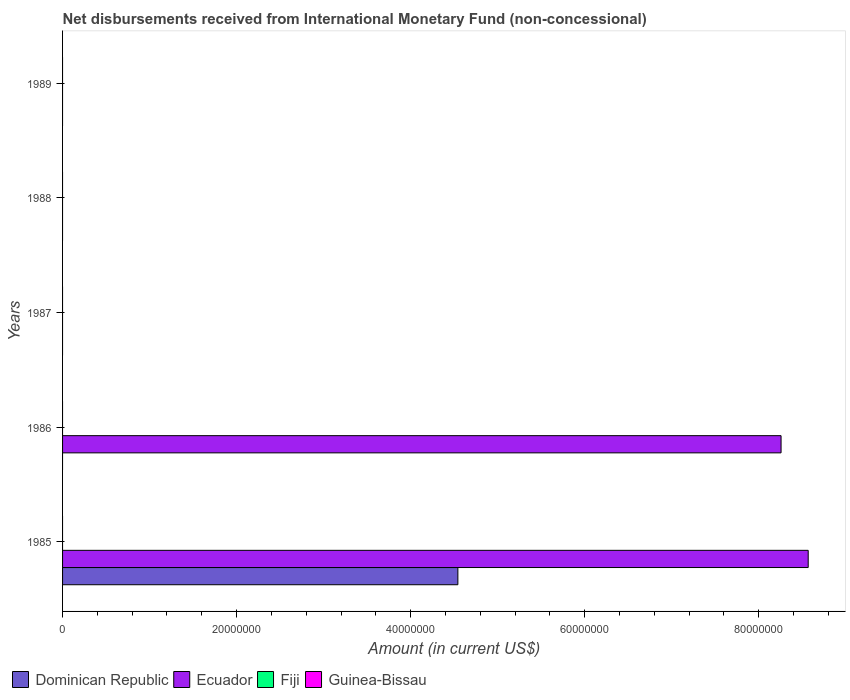How many bars are there on the 4th tick from the top?
Provide a succinct answer. 1. What is the label of the 3rd group of bars from the top?
Ensure brevity in your answer.  1987. In how many cases, is the number of bars for a given year not equal to the number of legend labels?
Your response must be concise. 5. What is the amount of disbursements received from International Monetary Fund in Ecuador in 1986?
Your response must be concise. 8.26e+07. Across all years, what is the maximum amount of disbursements received from International Monetary Fund in Ecuador?
Make the answer very short. 8.57e+07. What is the total amount of disbursements received from International Monetary Fund in Dominican Republic in the graph?
Provide a short and direct response. 4.54e+07. What is the difference between the amount of disbursements received from International Monetary Fund in Guinea-Bissau in 1987 and the amount of disbursements received from International Monetary Fund in Dominican Republic in 1985?
Keep it short and to the point. -4.54e+07. What is the average amount of disbursements received from International Monetary Fund in Dominican Republic per year?
Your response must be concise. 9.09e+06. What is the difference between the highest and the lowest amount of disbursements received from International Monetary Fund in Dominican Republic?
Your answer should be very brief. 4.54e+07. In how many years, is the amount of disbursements received from International Monetary Fund in Fiji greater than the average amount of disbursements received from International Monetary Fund in Fiji taken over all years?
Ensure brevity in your answer.  0. Is it the case that in every year, the sum of the amount of disbursements received from International Monetary Fund in Fiji and amount of disbursements received from International Monetary Fund in Dominican Republic is greater than the sum of amount of disbursements received from International Monetary Fund in Ecuador and amount of disbursements received from International Monetary Fund in Guinea-Bissau?
Provide a short and direct response. No. Is it the case that in every year, the sum of the amount of disbursements received from International Monetary Fund in Fiji and amount of disbursements received from International Monetary Fund in Guinea-Bissau is greater than the amount of disbursements received from International Monetary Fund in Ecuador?
Keep it short and to the point. No. How many years are there in the graph?
Keep it short and to the point. 5. Are the values on the major ticks of X-axis written in scientific E-notation?
Keep it short and to the point. No. Does the graph contain grids?
Give a very brief answer. No. Where does the legend appear in the graph?
Ensure brevity in your answer.  Bottom left. How many legend labels are there?
Ensure brevity in your answer.  4. What is the title of the graph?
Offer a terse response. Net disbursements received from International Monetary Fund (non-concessional). What is the label or title of the Y-axis?
Provide a succinct answer. Years. What is the Amount (in current US$) of Dominican Republic in 1985?
Provide a succinct answer. 4.54e+07. What is the Amount (in current US$) of Ecuador in 1985?
Keep it short and to the point. 8.57e+07. What is the Amount (in current US$) of Fiji in 1985?
Keep it short and to the point. 0. What is the Amount (in current US$) in Ecuador in 1986?
Make the answer very short. 8.26e+07. What is the Amount (in current US$) in Fiji in 1986?
Your response must be concise. 0. What is the Amount (in current US$) in Ecuador in 1987?
Give a very brief answer. 0. What is the Amount (in current US$) of Guinea-Bissau in 1987?
Offer a terse response. 0. What is the Amount (in current US$) in Guinea-Bissau in 1988?
Provide a short and direct response. 0. What is the Amount (in current US$) of Dominican Republic in 1989?
Offer a very short reply. 0. What is the Amount (in current US$) in Ecuador in 1989?
Your answer should be very brief. 0. Across all years, what is the maximum Amount (in current US$) in Dominican Republic?
Keep it short and to the point. 4.54e+07. Across all years, what is the maximum Amount (in current US$) of Ecuador?
Your response must be concise. 8.57e+07. What is the total Amount (in current US$) of Dominican Republic in the graph?
Provide a succinct answer. 4.54e+07. What is the total Amount (in current US$) in Ecuador in the graph?
Offer a terse response. 1.68e+08. What is the total Amount (in current US$) in Fiji in the graph?
Provide a short and direct response. 0. What is the total Amount (in current US$) in Guinea-Bissau in the graph?
Your answer should be very brief. 0. What is the difference between the Amount (in current US$) of Ecuador in 1985 and that in 1986?
Keep it short and to the point. 3.12e+06. What is the difference between the Amount (in current US$) of Dominican Republic in 1985 and the Amount (in current US$) of Ecuador in 1986?
Your response must be concise. -3.71e+07. What is the average Amount (in current US$) of Dominican Republic per year?
Your response must be concise. 9.09e+06. What is the average Amount (in current US$) in Ecuador per year?
Make the answer very short. 3.37e+07. What is the average Amount (in current US$) in Fiji per year?
Offer a terse response. 0. What is the average Amount (in current US$) of Guinea-Bissau per year?
Give a very brief answer. 0. In the year 1985, what is the difference between the Amount (in current US$) of Dominican Republic and Amount (in current US$) of Ecuador?
Your response must be concise. -4.03e+07. What is the ratio of the Amount (in current US$) of Ecuador in 1985 to that in 1986?
Provide a short and direct response. 1.04. What is the difference between the highest and the lowest Amount (in current US$) in Dominican Republic?
Make the answer very short. 4.54e+07. What is the difference between the highest and the lowest Amount (in current US$) of Ecuador?
Provide a short and direct response. 8.57e+07. 